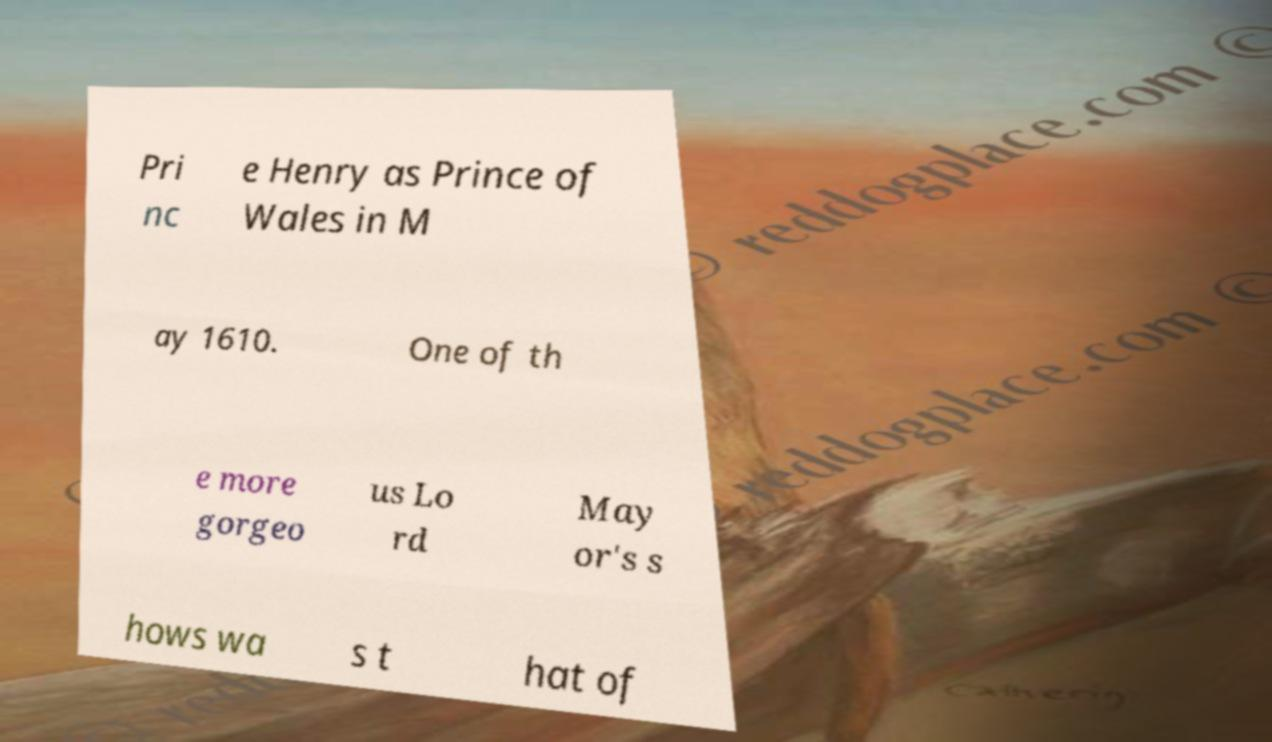Can you accurately transcribe the text from the provided image for me? Pri nc e Henry as Prince of Wales in M ay 1610. One of th e more gorgeo us Lo rd May or's s hows wa s t hat of 